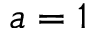<formula> <loc_0><loc_0><loc_500><loc_500>a = 1</formula> 